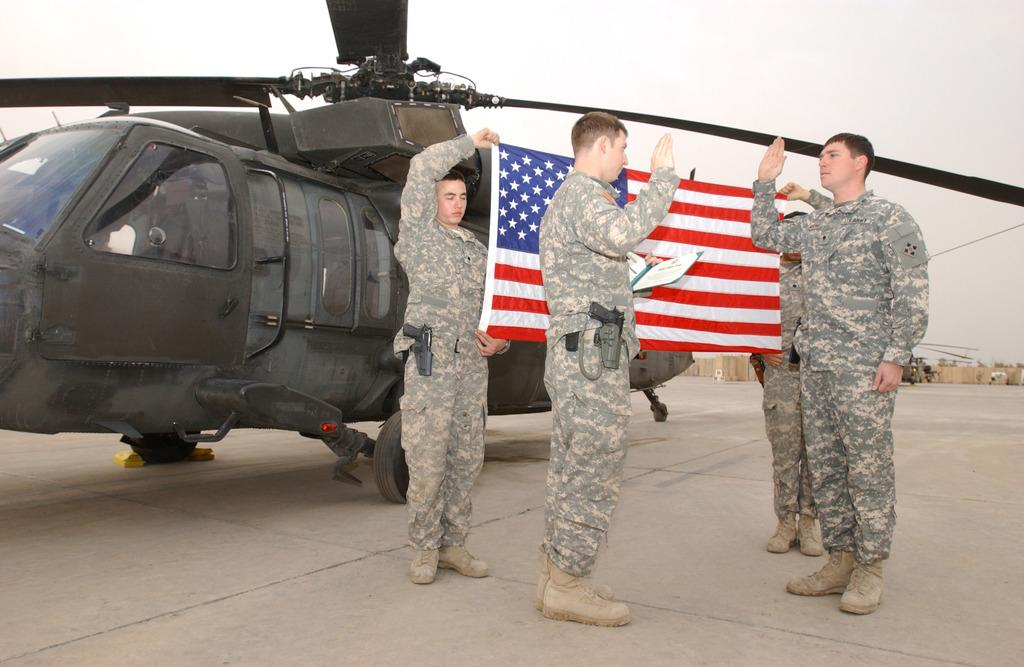How many people are in the image? There are four men in the image. What are two of the men doing in the image? Two of the men are holding a flag. What can be seen in the background of the image? There is a helicopter and the sky visible in the background of the image. What type of knot is used to secure the flag in the image? There is no mention of a knot in the image, as the flag is being held by two men. --- Facts: 1. There is a car in the image. 2. The car is red. 3. The car has four wheels. 4. There is a road in the image. 5. The road is paved. Absurd Topics: parrot, sand, mountain Conversation: What is the main subject of the image? The main subject of the image is a car. What color is the car? The car is red. How many wheels does the car have? The car has four wheels. What type of surface is the car on? There is a road in the image, and it is paved. Reasoning: Let's think step by step in order to produce the conversation. We start by identifying the main subject of the image, which is the car. Then, we describe the car's color and the number of wheels it has. Finally, we mention the type of surface the car is on, which is a paved road. Each question is designed to elicit a specific detail about the image that is known from the provided facts. Absurd Question/Answer: Can you see a parrot perched on the car in the image? No, there is no parrot present in the image. --- Facts: 1. There is a group of people in the image. 2. The people are wearing hats. 3. The people are holding umbrellas. 4. It is raining in the image. 5. The ground is wet. Absurd Topics: snow, fire, bicycle Conversation: How many people are in the image? There is a group of people in the image. What are the people wearing in the image? The people are wearing hats. What are the people holding in the image? The people are holding umbrellas. What is the weather like in the image? It is raining in the image, and the ground is wet. Reasoning: Let's think step by step in order to produce the conversation. We start by identifying the main subject of the image, which is a group of people. Then, we describe what the people are wearing (hats) and holding (umbrellas). Finally, we mention the weather conditions in the image, which include rain and wet ground. Each question is designed to el 